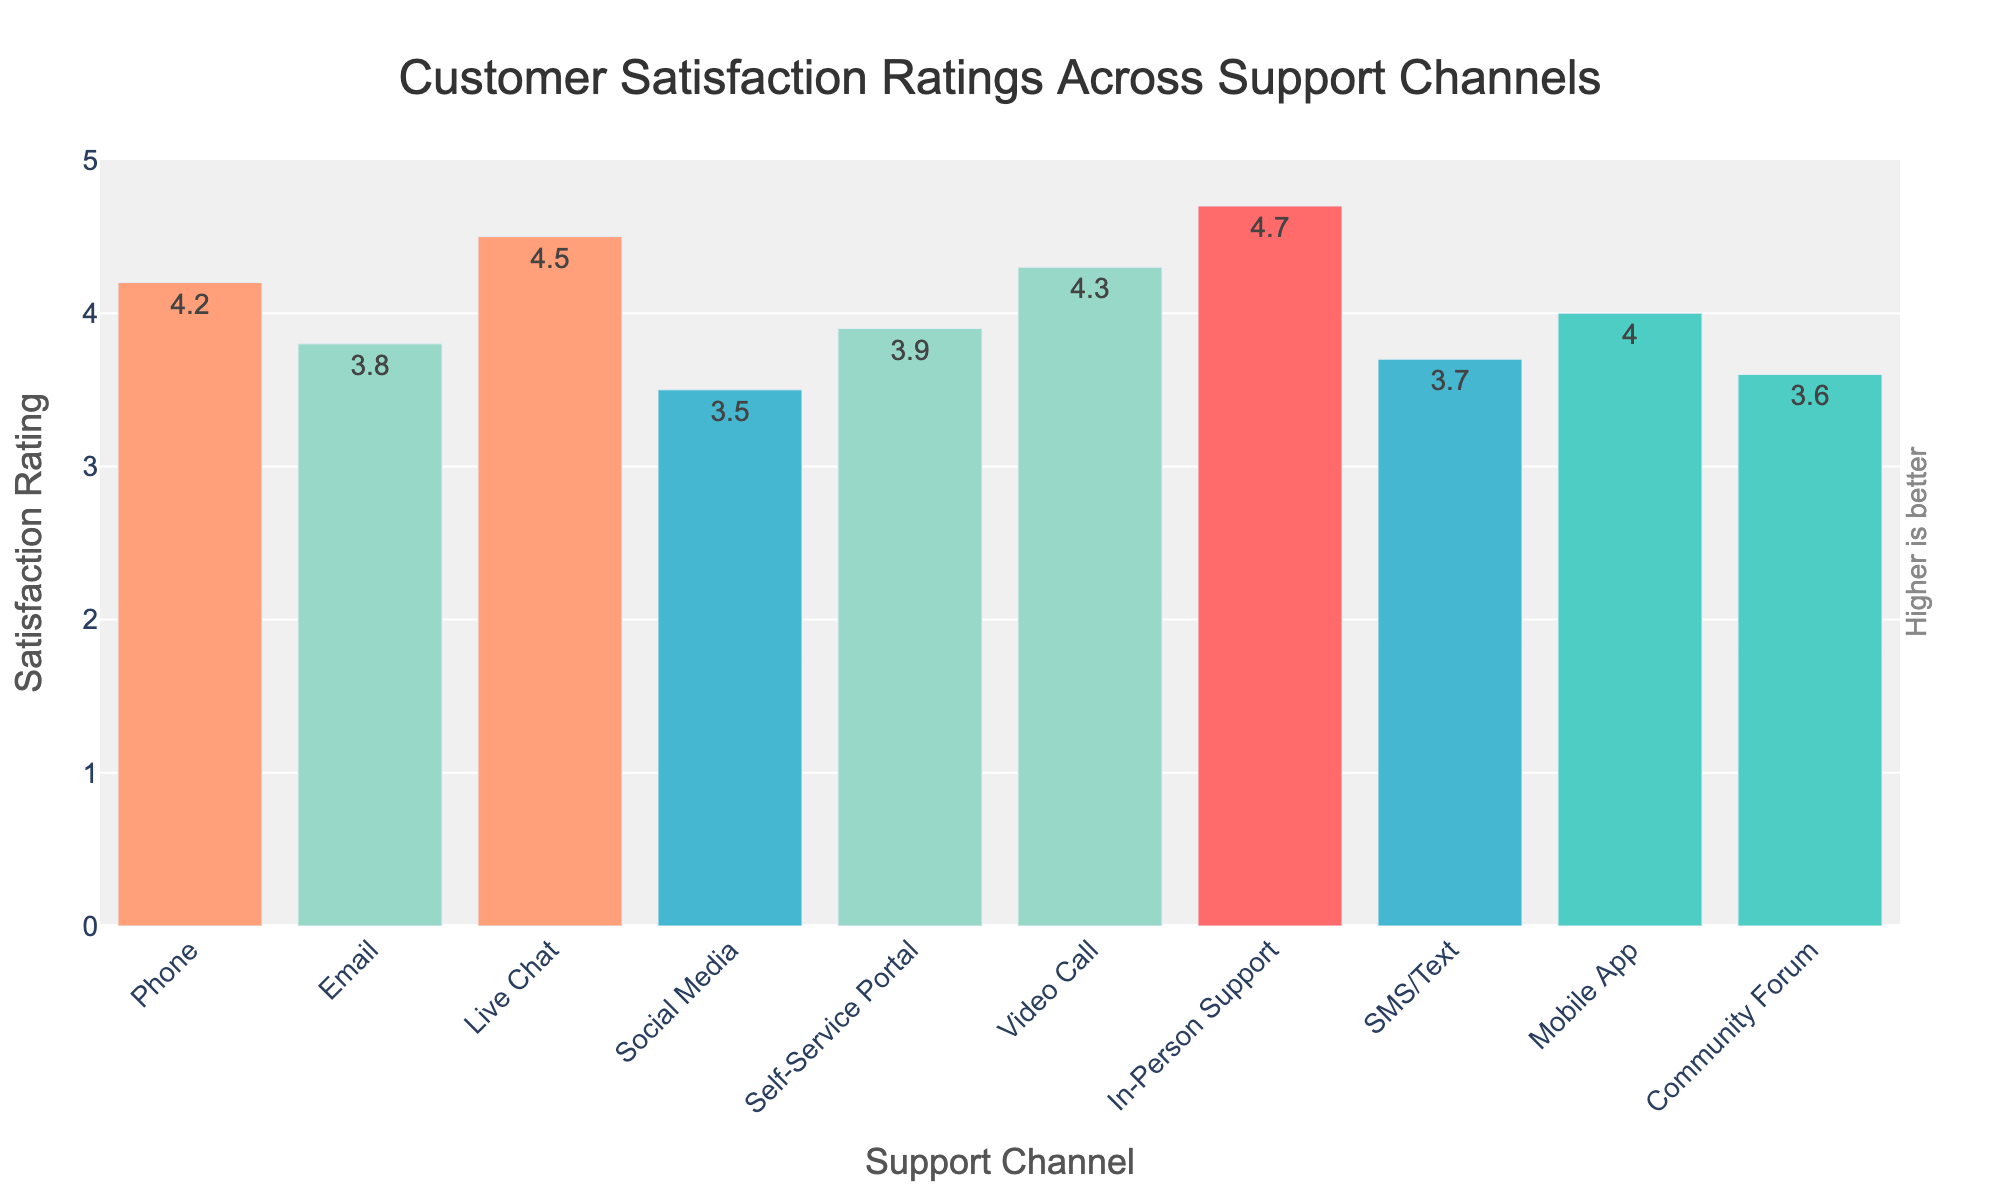Which support channel has the highest customer satisfaction rating? Look at the highest bar in the chart; it corresponds to the "In-Person Support" channel.
Answer: In-Person Support Which support channel has the lowest customer satisfaction rating? Look at the shortest bar in the chart; it corresponds to the "Social Media" channel.
Answer: Social Media What are the customer satisfaction ratings for In-Person Support and Live Chat? Check the height of the bars labeled "In-Person Support" and "Live Chat." The ratings are 4.7 and 4.5 respectively.
Answer: 4.7 and 4.5 What is the difference in customer satisfaction ratings between Phone and Email support channels? Subtract the satisfaction rating of "Email" from the rating of "Phone" (4.2 - 3.8).
Answer: 0.4 What is the average customer satisfaction rating across all support channels? Sum all the ratings and divide by the number of channels: (4.2 + 3.8 + 4.5 + 3.5 + 3.9 + 4.3 + 4.7 + 3.7 + 4.0 + 3.6) / 10.
Answer: 4.02 Which channels have customer satisfaction ratings higher than 4.0? Identify the bars that are taller than the 4.0 mark: "Phone," "Live Chat," "Video Call," and "In-Person Support."
Answer: Phone, Live Chat, Video Call, In-Person Support Which channel has a higher satisfaction rating: Video Call or Mobile App? Compare the heights of bars for "Video Call" and "Mobile App." Video Call has a rating of 4.3, and Mobile App has a rating of 4.0.
Answer: Video Call How much higher is the satisfaction rating for Video Call compared to Social Media? Subtract the "Social Media" rating from the "Video Call" rating (4.3 - 3.5).
Answer: 0.8 Among Phone, Email, and Live Chat, which support channel has the median satisfaction rating? Arrange the ratings of "Phone" (4.2), "Email" (3.8), and "Live Chat" (4.5) and find the middle value.
Answer: Phone What's the combined customer satisfaction rating for SMS/Text and Community Forum? Sum the ratings for "SMS/Text" (3.7) and "Community Forum" (3.6).
Answer: 7.3 